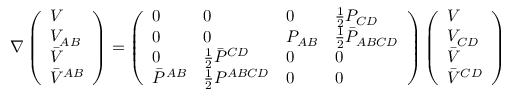<formula> <loc_0><loc_0><loc_500><loc_500>\nabla \left ( \begin{array} { l } { V } \\ { { V _ { A B } } } \\ { { \bar { V } } } \\ { { \bar { V } ^ { A B } } } \end{array} \right ) = \left ( \begin{array} { l l l l } { 0 } & { 0 } & { 0 } & { { { \frac { 1 } { 2 } } P _ { C D } } } \\ { 0 } & { 0 } & { { P _ { A B } } } & { { { \frac { 1 } { 2 } } \bar { P } _ { A B C D } } } \\ { 0 } & { { { \frac { 1 } { 2 } } \bar { P } ^ { C D } } } & { 0 } & { 0 } \\ { { \bar { P } ^ { A B } } } & { { { \frac { 1 } { 2 } } P ^ { A B C D } } } & { 0 } & { 0 } \end{array} \right ) \left ( \begin{array} { l } { V } \\ { { V _ { C D } } } \\ { { \bar { V } } } \\ { { \bar { V } ^ { C D } } } \end{array} \right )</formula> 